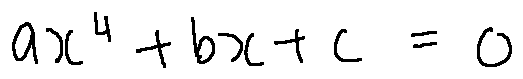<formula> <loc_0><loc_0><loc_500><loc_500>a x ^ { 4 } + b x + c = 0</formula> 